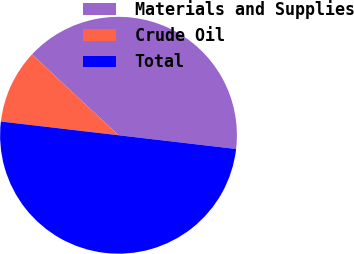<chart> <loc_0><loc_0><loc_500><loc_500><pie_chart><fcel>Materials and Supplies<fcel>Crude Oil<fcel>Total<nl><fcel>39.89%<fcel>10.11%<fcel>50.0%<nl></chart> 